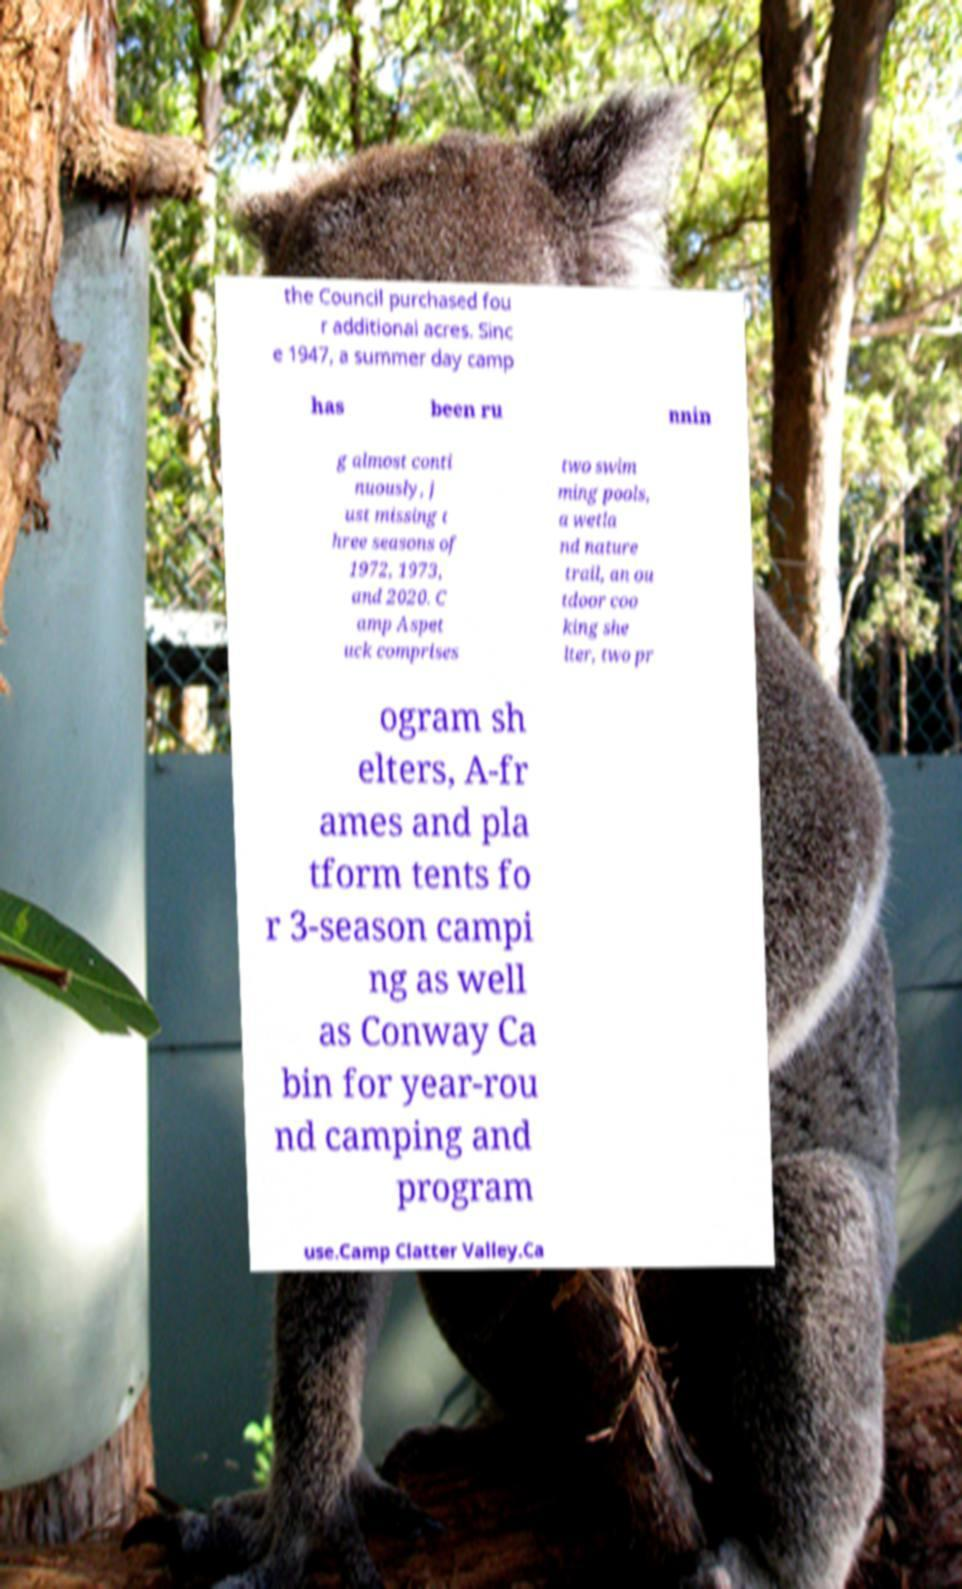Please identify and transcribe the text found in this image. the Council purchased fou r additional acres. Sinc e 1947, a summer day camp has been ru nnin g almost conti nuously, j ust missing t hree seasons of 1972, 1973, and 2020. C amp Aspet uck comprises two swim ming pools, a wetla nd nature trail, an ou tdoor coo king she lter, two pr ogram sh elters, A-fr ames and pla tform tents fo r 3-season campi ng as well as Conway Ca bin for year-rou nd camping and program use.Camp Clatter Valley.Ca 